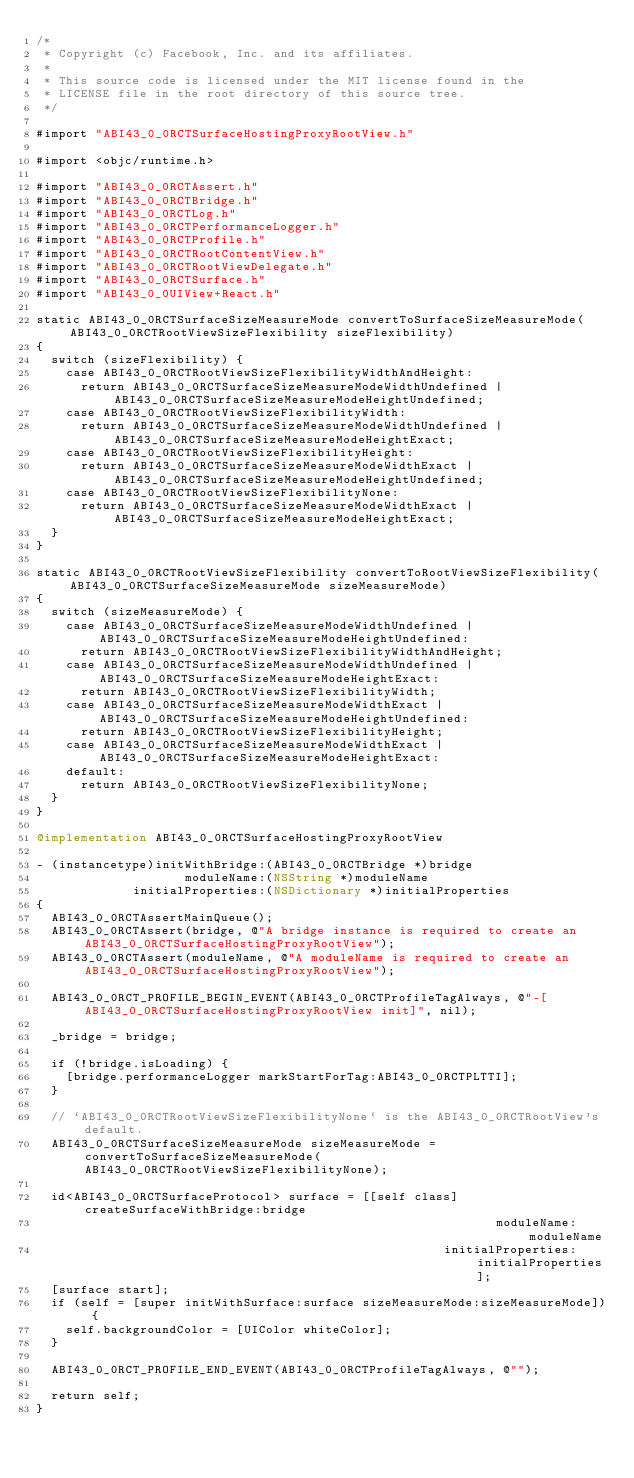<code> <loc_0><loc_0><loc_500><loc_500><_ObjectiveC_>/*
 * Copyright (c) Facebook, Inc. and its affiliates.
 *
 * This source code is licensed under the MIT license found in the
 * LICENSE file in the root directory of this source tree.
 */

#import "ABI43_0_0RCTSurfaceHostingProxyRootView.h"

#import <objc/runtime.h>

#import "ABI43_0_0RCTAssert.h"
#import "ABI43_0_0RCTBridge.h"
#import "ABI43_0_0RCTLog.h"
#import "ABI43_0_0RCTPerformanceLogger.h"
#import "ABI43_0_0RCTProfile.h"
#import "ABI43_0_0RCTRootContentView.h"
#import "ABI43_0_0RCTRootViewDelegate.h"
#import "ABI43_0_0RCTSurface.h"
#import "ABI43_0_0UIView+React.h"

static ABI43_0_0RCTSurfaceSizeMeasureMode convertToSurfaceSizeMeasureMode(ABI43_0_0RCTRootViewSizeFlexibility sizeFlexibility)
{
  switch (sizeFlexibility) {
    case ABI43_0_0RCTRootViewSizeFlexibilityWidthAndHeight:
      return ABI43_0_0RCTSurfaceSizeMeasureModeWidthUndefined | ABI43_0_0RCTSurfaceSizeMeasureModeHeightUndefined;
    case ABI43_0_0RCTRootViewSizeFlexibilityWidth:
      return ABI43_0_0RCTSurfaceSizeMeasureModeWidthUndefined | ABI43_0_0RCTSurfaceSizeMeasureModeHeightExact;
    case ABI43_0_0RCTRootViewSizeFlexibilityHeight:
      return ABI43_0_0RCTSurfaceSizeMeasureModeWidthExact | ABI43_0_0RCTSurfaceSizeMeasureModeHeightUndefined;
    case ABI43_0_0RCTRootViewSizeFlexibilityNone:
      return ABI43_0_0RCTSurfaceSizeMeasureModeWidthExact | ABI43_0_0RCTSurfaceSizeMeasureModeHeightExact;
  }
}

static ABI43_0_0RCTRootViewSizeFlexibility convertToRootViewSizeFlexibility(ABI43_0_0RCTSurfaceSizeMeasureMode sizeMeasureMode)
{
  switch (sizeMeasureMode) {
    case ABI43_0_0RCTSurfaceSizeMeasureModeWidthUndefined | ABI43_0_0RCTSurfaceSizeMeasureModeHeightUndefined:
      return ABI43_0_0RCTRootViewSizeFlexibilityWidthAndHeight;
    case ABI43_0_0RCTSurfaceSizeMeasureModeWidthUndefined | ABI43_0_0RCTSurfaceSizeMeasureModeHeightExact:
      return ABI43_0_0RCTRootViewSizeFlexibilityWidth;
    case ABI43_0_0RCTSurfaceSizeMeasureModeWidthExact | ABI43_0_0RCTSurfaceSizeMeasureModeHeightUndefined:
      return ABI43_0_0RCTRootViewSizeFlexibilityHeight;
    case ABI43_0_0RCTSurfaceSizeMeasureModeWidthExact | ABI43_0_0RCTSurfaceSizeMeasureModeHeightExact:
    default:
      return ABI43_0_0RCTRootViewSizeFlexibilityNone;
  }
}

@implementation ABI43_0_0RCTSurfaceHostingProxyRootView

- (instancetype)initWithBridge:(ABI43_0_0RCTBridge *)bridge
                    moduleName:(NSString *)moduleName
             initialProperties:(NSDictionary *)initialProperties
{
  ABI43_0_0RCTAssertMainQueue();
  ABI43_0_0RCTAssert(bridge, @"A bridge instance is required to create an ABI43_0_0RCTSurfaceHostingProxyRootView");
  ABI43_0_0RCTAssert(moduleName, @"A moduleName is required to create an ABI43_0_0RCTSurfaceHostingProxyRootView");

  ABI43_0_0RCT_PROFILE_BEGIN_EVENT(ABI43_0_0RCTProfileTagAlways, @"-[ABI43_0_0RCTSurfaceHostingProxyRootView init]", nil);

  _bridge = bridge;

  if (!bridge.isLoading) {
    [bridge.performanceLogger markStartForTag:ABI43_0_0RCTPLTTI];
  }

  // `ABI43_0_0RCTRootViewSizeFlexibilityNone` is the ABI43_0_0RCTRootView's default.
  ABI43_0_0RCTSurfaceSizeMeasureMode sizeMeasureMode = convertToSurfaceSizeMeasureMode(ABI43_0_0RCTRootViewSizeFlexibilityNone);

  id<ABI43_0_0RCTSurfaceProtocol> surface = [[self class] createSurfaceWithBridge:bridge
                                                              moduleName:moduleName
                                                       initialProperties:initialProperties];
  [surface start];
  if (self = [super initWithSurface:surface sizeMeasureMode:sizeMeasureMode]) {
    self.backgroundColor = [UIColor whiteColor];
  }

  ABI43_0_0RCT_PROFILE_END_EVENT(ABI43_0_0RCTProfileTagAlways, @"");

  return self;
}
</code> 